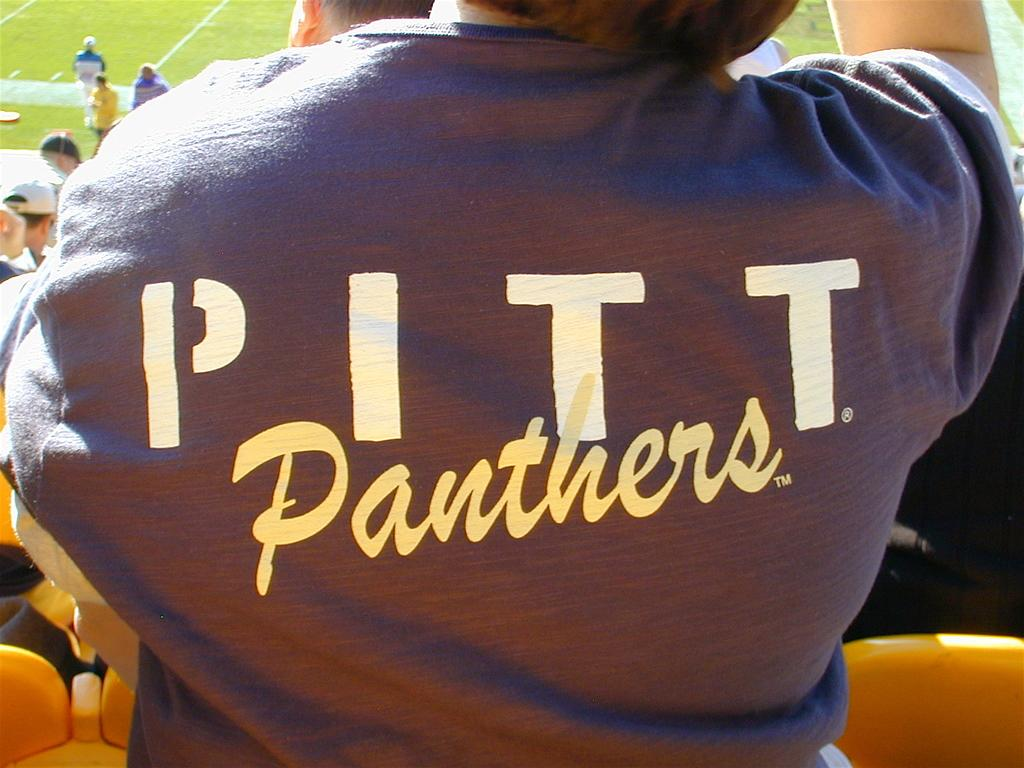<image>
Write a terse but informative summary of the picture. Pitt Panthers written on the back of a dark t-shirt. 